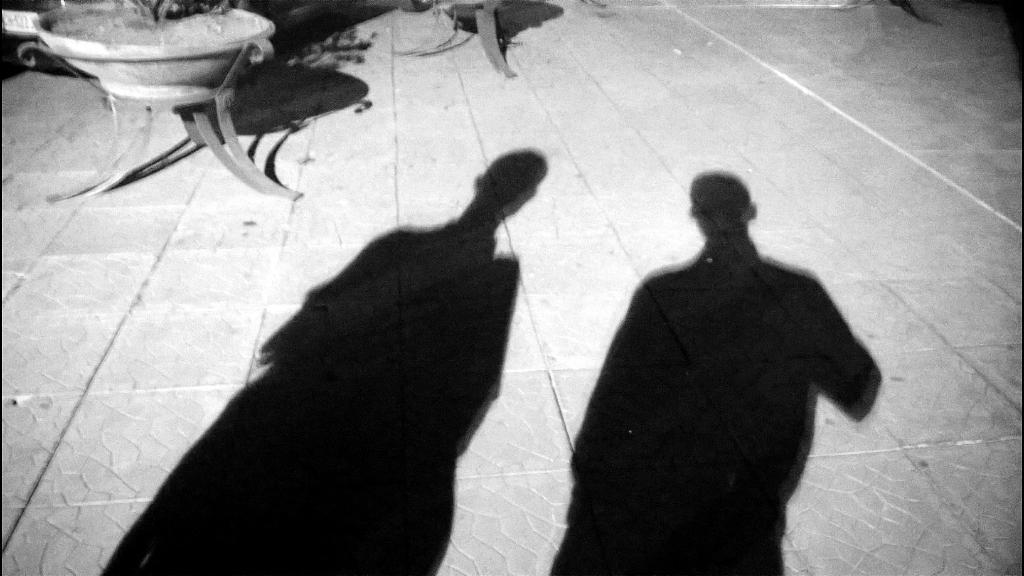What can be seen at the bottom of the image? The ground is visible in the image. What is located at the top of the image? There are objects at the top of the image. Can you describe the shadows in the image? The shadows of people are present on the ground in the image. How many combs are being offered to the flock in the image? There are no combs or flocks present in the image. 